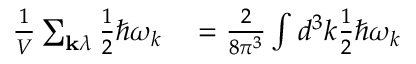Convert formula to latex. <formula><loc_0><loc_0><loc_500><loc_500>\begin{array} { r l } { { \frac { 1 } { V } } \sum _ { k \lambda } { \frac { 1 } { 2 } } \hbar { \omega } _ { k } } & = { \frac { 2 } { 8 \pi ^ { 3 } } } \int d ^ { 3 } k { \frac { 1 } { 2 } } \hbar { \omega } _ { k } } \end{array}</formula> 